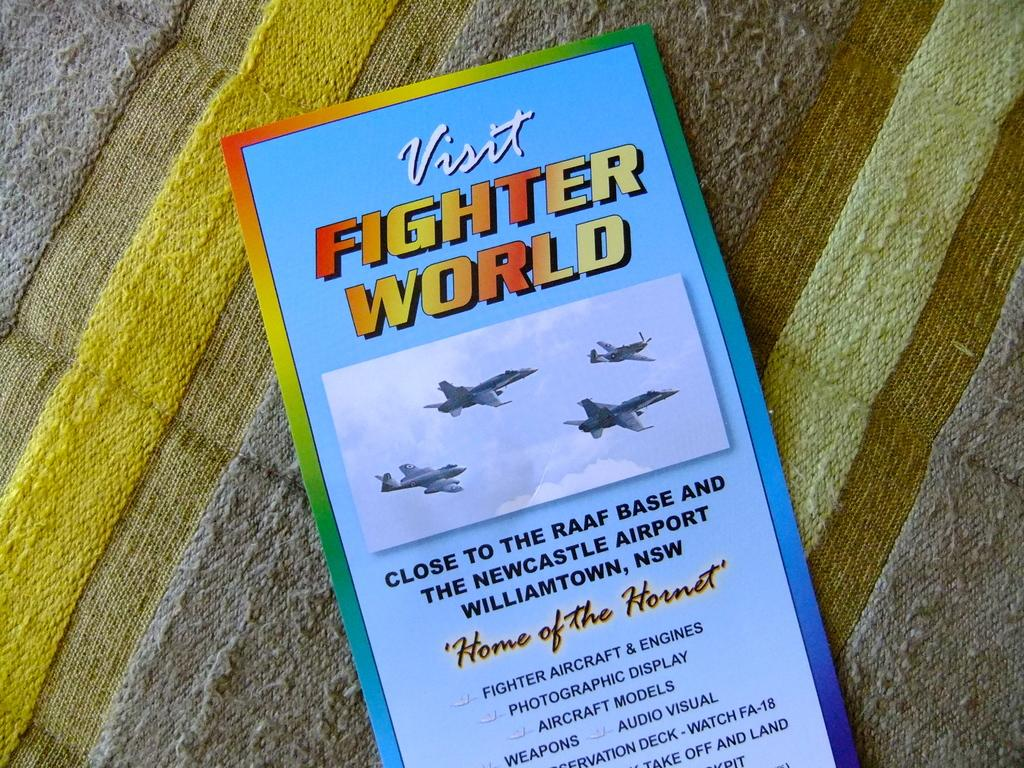<image>
Relay a brief, clear account of the picture shown. A pamphlet for Fighter World in Williamtown has fighter jets on it. 